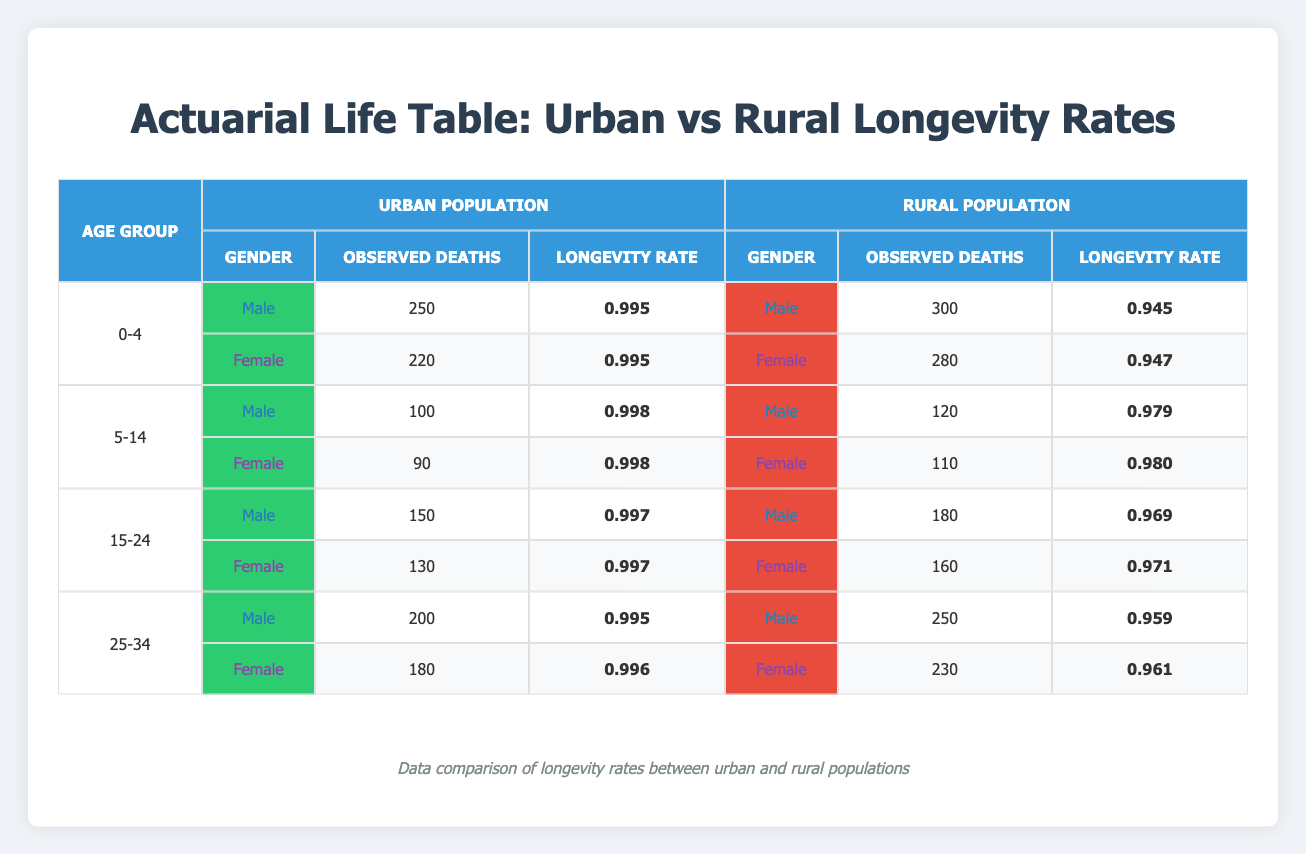What is the longevity rate for males aged 0-4 in the urban population? According to the table, the longevity rate for males aged 0-4 in the urban population is directly listed, showing a longevity rate of 0.995.
Answer: 0.995 What is the longevity rate for females aged 25-34 in the rural population? The table reveals the longevity rate for females in the 25-34 age group specifically as 0.961, allowing us to answer this question directly.
Answer: 0.961 How many observed deaths were recorded for males aged 15-24 in the rural population? In the table, the number of observed deaths for males in the rural population aged 15-24 is indicated as 180, which is straightforward to find.
Answer: 180 Do urban females aged 5-14 have a higher longevity rate than rural females in the same age group? The longevity rate for urban females aged 5-14 is listed as 0.998, while the rural female longevity rate for that group is 0.980. Since 0.998 > 0.980, the answer is yes.
Answer: Yes What is the difference in longevity rates between urban males aged 0-4 and rural males in the same age group? For urban males aged 0-4, the longevity rate is 0.995, and for rural males, it is 0.945. The difference is calculated by subtracting the rural rate from the urban rate: 0.995 - 0.945 = 0.050.
Answer: 0.050 What is the average longevity rate for females across all age groups in the urban population? The longevity rates for urban females in the respective age groups are 0.995 (0-4) + 0.998 (5-14) + 0.997 (15-24) + 0.996 (25-34). Summing these gives us 3.986, and dividing by the number of age groups (4) results in an average of 0.9965, rounded to 0.997.
Answer: 0.997 Are there more observed deaths for males aged 25-34 in the rural population than in the urban population? The observed deaths for rural males aged 25-34 are 250, while for urban males in the same group, it is 200. Comparing these numbers indicates that 250 > 200, confirming more observed deaths in the rural population.
Answer: Yes What is the total number of observed deaths for females across all age groups in the urban population? The observed deaths for urban females are 220 (0-4) + 90 (5-14) + 130 (15-24) + 180 (25-34). When summed, these equal 620, giving us the total observed deaths.
Answer: 620 What percentage of the total population does the longevity rate of 0.995 represent for urban males aged 0-4? The longevity rate of 0.995 indicates that 99.5% of the total population, which consists of 50,000 males aged 0-4, are expected to survive. This can be derived as (0.995 * 50000) which approximately equals 49,750.
Answer: 49,750 What is the ranking of longevity rates from highest to lowest for all urban males across age groups? The longevity rates for urban males by age group are: 0.995 (0-4), 0.998 (5-14), 0.997 (15-24), and 0.995 (25-34). Ranking these from highest to lowest, we find 0.998 (5-14), then 0.997 (15-24), followed by 0.995 (0-4 and 25-34).
Answer: 5-14 > 15-24 > 0-4 = 25-34 